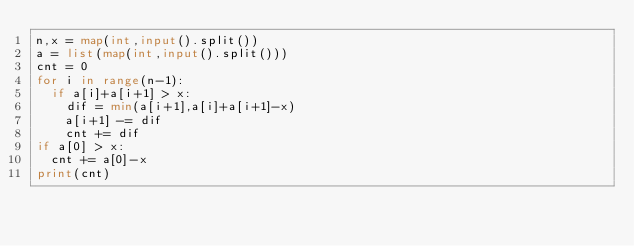<code> <loc_0><loc_0><loc_500><loc_500><_Python_>n,x = map(int,input().split())
a = list(map(int,input().split()))
cnt = 0
for i in range(n-1):
  if a[i]+a[i+1] > x:
    dif = min(a[i+1],a[i]+a[i+1]-x)
    a[i+1] -= dif
    cnt += dif
if a[0] > x:
  cnt += a[0]-x
print(cnt)</code> 